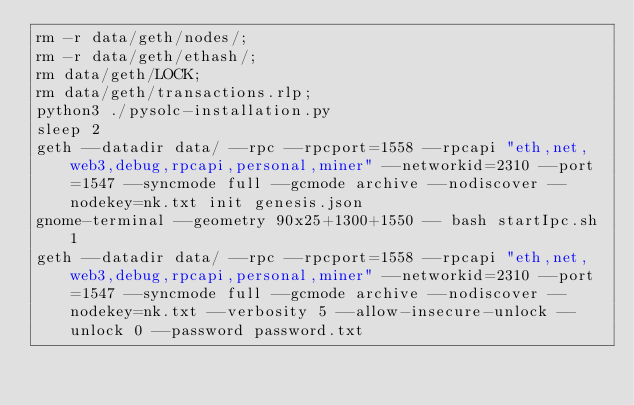<code> <loc_0><loc_0><loc_500><loc_500><_Bash_>rm -r data/geth/nodes/;
rm -r data/geth/ethash/;
rm data/geth/LOCK;
rm data/geth/transactions.rlp;
python3 ./pysolc-installation.py
sleep 2
geth --datadir data/ --rpc --rpcport=1558 --rpcapi "eth,net,web3,debug,rpcapi,personal,miner" --networkid=2310 --port=1547 --syncmode full --gcmode archive --nodiscover --nodekey=nk.txt init genesis.json
gnome-terminal --geometry 90x25+1300+1550 -- bash startIpc.sh 1
geth --datadir data/ --rpc --rpcport=1558 --rpcapi "eth,net,web3,debug,rpcapi,personal,miner" --networkid=2310 --port=1547 --syncmode full --gcmode archive --nodiscover --nodekey=nk.txt --verbosity 5 --allow-insecure-unlock --unlock 0 --password password.txt</code> 